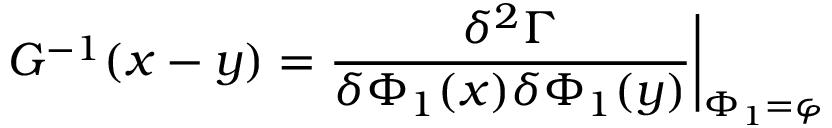<formula> <loc_0><loc_0><loc_500><loc_500>G ^ { - 1 } ( x - y ) = \frac { \delta ^ { 2 } \Gamma } { \delta \Phi _ { 1 } ( x ) \delta \Phi _ { 1 } ( y ) } \Big | _ { \Phi _ { 1 } = \varphi }</formula> 